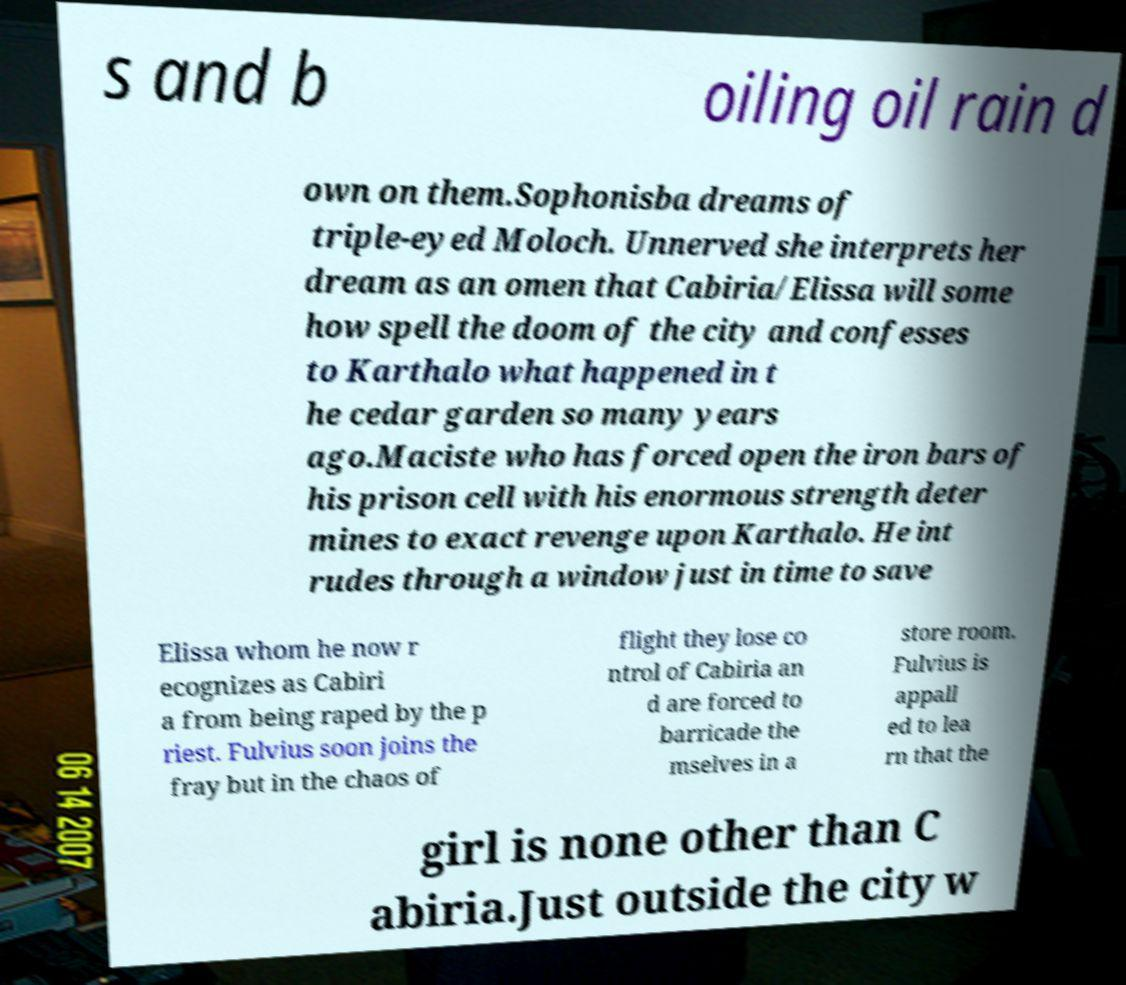There's text embedded in this image that I need extracted. Can you transcribe it verbatim? s and b oiling oil rain d own on them.Sophonisba dreams of triple-eyed Moloch. Unnerved she interprets her dream as an omen that Cabiria/Elissa will some how spell the doom of the city and confesses to Karthalo what happened in t he cedar garden so many years ago.Maciste who has forced open the iron bars of his prison cell with his enormous strength deter mines to exact revenge upon Karthalo. He int rudes through a window just in time to save Elissa whom he now r ecognizes as Cabiri a from being raped by the p riest. Fulvius soon joins the fray but in the chaos of flight they lose co ntrol of Cabiria an d are forced to barricade the mselves in a store room. Fulvius is appall ed to lea rn that the girl is none other than C abiria.Just outside the city w 